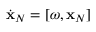Convert formula to latex. <formula><loc_0><loc_0><loc_500><loc_500>\dot { x } _ { N } = [ \omega , { x } _ { N } ]</formula> 